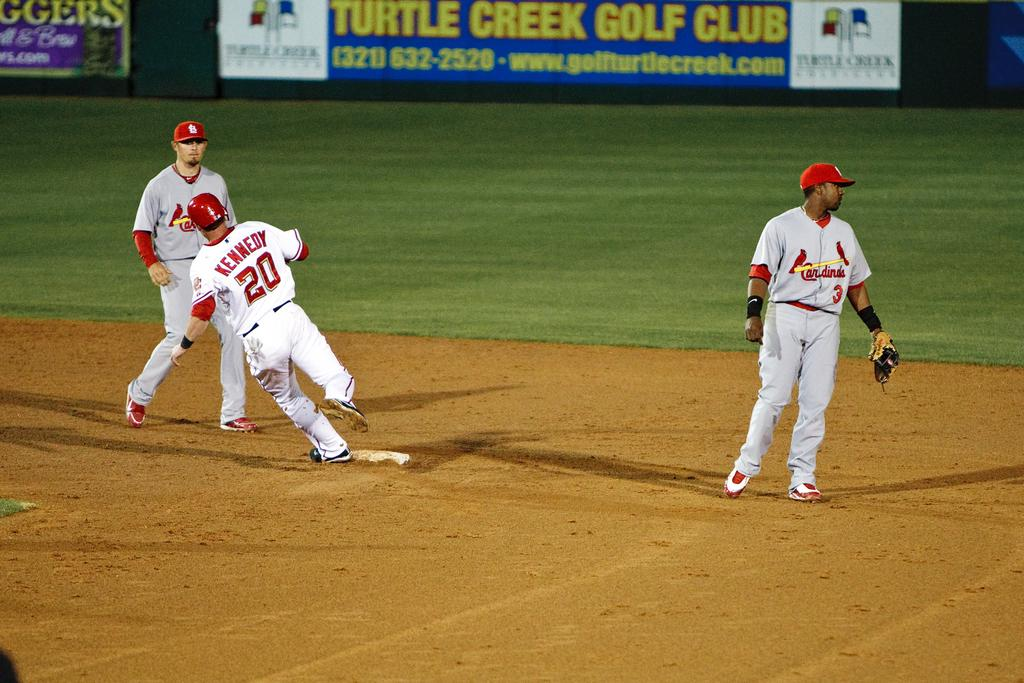<image>
Summarize the visual content of the image. a Cardinals baseball player looks to the side of the field while number 20 runs to the base 